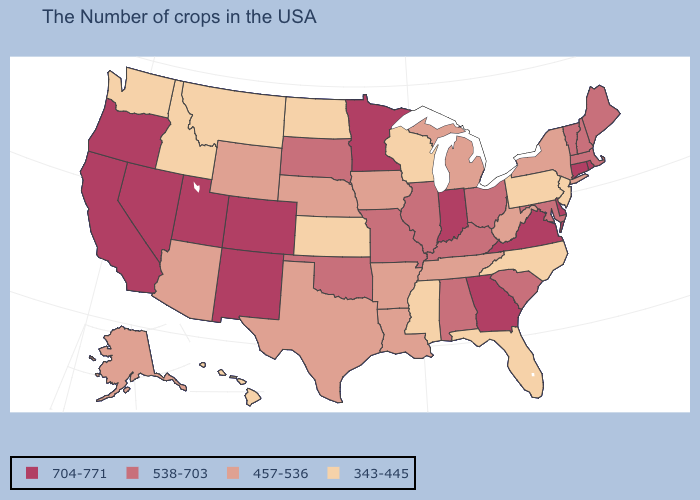Does the map have missing data?
Write a very short answer. No. What is the value of Wisconsin?
Concise answer only. 343-445. What is the value of New Jersey?
Be succinct. 343-445. Name the states that have a value in the range 704-771?
Keep it brief. Rhode Island, Connecticut, Delaware, Virginia, Georgia, Indiana, Minnesota, Colorado, New Mexico, Utah, Nevada, California, Oregon. What is the lowest value in states that border Delaware?
Write a very short answer. 343-445. Does the map have missing data?
Write a very short answer. No. Which states have the highest value in the USA?
Quick response, please. Rhode Island, Connecticut, Delaware, Virginia, Georgia, Indiana, Minnesota, Colorado, New Mexico, Utah, Nevada, California, Oregon. How many symbols are there in the legend?
Quick response, please. 4. Name the states that have a value in the range 457-536?
Answer briefly. New York, West Virginia, Michigan, Tennessee, Louisiana, Arkansas, Iowa, Nebraska, Texas, Wyoming, Arizona, Alaska. Which states hav the highest value in the Northeast?
Be succinct. Rhode Island, Connecticut. What is the value of South Dakota?
Concise answer only. 538-703. Among the states that border Utah , which have the highest value?
Give a very brief answer. Colorado, New Mexico, Nevada. What is the value of Nevada?
Quick response, please. 704-771. Does Illinois have the lowest value in the MidWest?
Write a very short answer. No. What is the lowest value in the South?
Concise answer only. 343-445. 